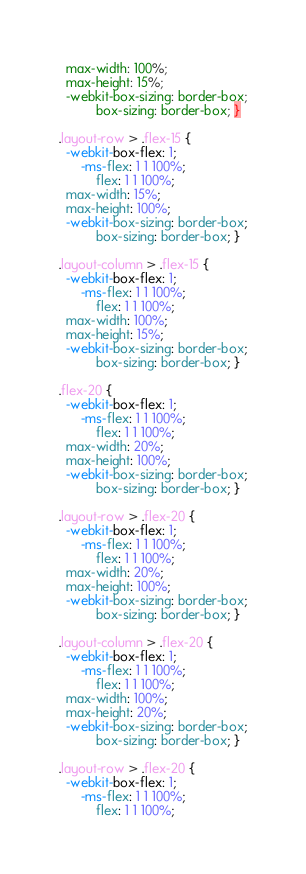Convert code to text. <code><loc_0><loc_0><loc_500><loc_500><_CSS_>  max-width: 100%;
  max-height: 15%;
  -webkit-box-sizing: border-box;
          box-sizing: border-box; }

.layout-row > .flex-15 {
  -webkit-box-flex: 1;
      -ms-flex: 1 1 100%;
          flex: 1 1 100%;
  max-width: 15%;
  max-height: 100%;
  -webkit-box-sizing: border-box;
          box-sizing: border-box; }

.layout-column > .flex-15 {
  -webkit-box-flex: 1;
      -ms-flex: 1 1 100%;
          flex: 1 1 100%;
  max-width: 100%;
  max-height: 15%;
  -webkit-box-sizing: border-box;
          box-sizing: border-box; }

.flex-20 {
  -webkit-box-flex: 1;
      -ms-flex: 1 1 100%;
          flex: 1 1 100%;
  max-width: 20%;
  max-height: 100%;
  -webkit-box-sizing: border-box;
          box-sizing: border-box; }

.layout-row > .flex-20 {
  -webkit-box-flex: 1;
      -ms-flex: 1 1 100%;
          flex: 1 1 100%;
  max-width: 20%;
  max-height: 100%;
  -webkit-box-sizing: border-box;
          box-sizing: border-box; }

.layout-column > .flex-20 {
  -webkit-box-flex: 1;
      -ms-flex: 1 1 100%;
          flex: 1 1 100%;
  max-width: 100%;
  max-height: 20%;
  -webkit-box-sizing: border-box;
          box-sizing: border-box; }

.layout-row > .flex-20 {
  -webkit-box-flex: 1;
      -ms-flex: 1 1 100%;
          flex: 1 1 100%;</code> 